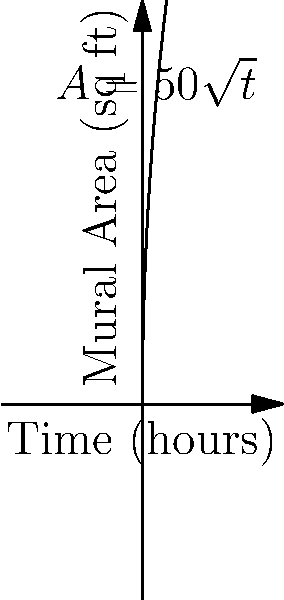You're painting a mural for a community art project. The area $A$ (in square feet) of the mural covered after $t$ hours is given by the function $A(t) = 50\sqrt{t}$. What is the rate at which the mural area is increasing after 4 hours of painting? To find the rate at which the mural area is increasing after 4 hours, we need to calculate the derivative of the function $A(t)$ and evaluate it at $t=4$. Let's follow these steps:

1) The given function is $A(t) = 50\sqrt{t}$

2) To find the derivative, we use the power rule and chain rule:
   $$\frac{d}{dt}(50\sqrt{t}) = 50 \cdot \frac{1}{2\sqrt{t}} = \frac{25}{\sqrt{t}}$$

3) This derivative $A'(t) = \frac{25}{\sqrt{t}}$ represents the rate of change of the mural area at any time $t$.

4) To find the rate after 4 hours, we substitute $t=4$ into this expression:
   $$A'(4) = \frac{25}{\sqrt{4}} = \frac{25}{2} = 12.5$$

5) Therefore, after 4 hours, the mural area is increasing at a rate of 12.5 square feet per hour.
Answer: 12.5 sq ft/hr 